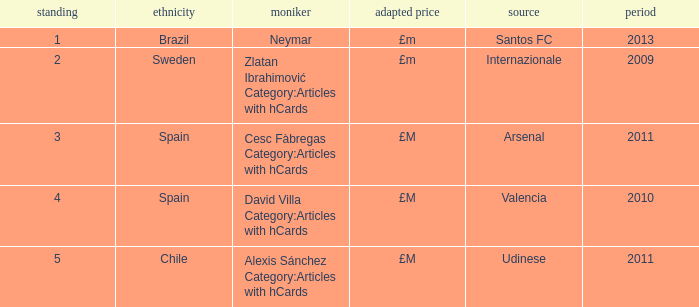Where is the ranked 2 players from? Internazionale. 